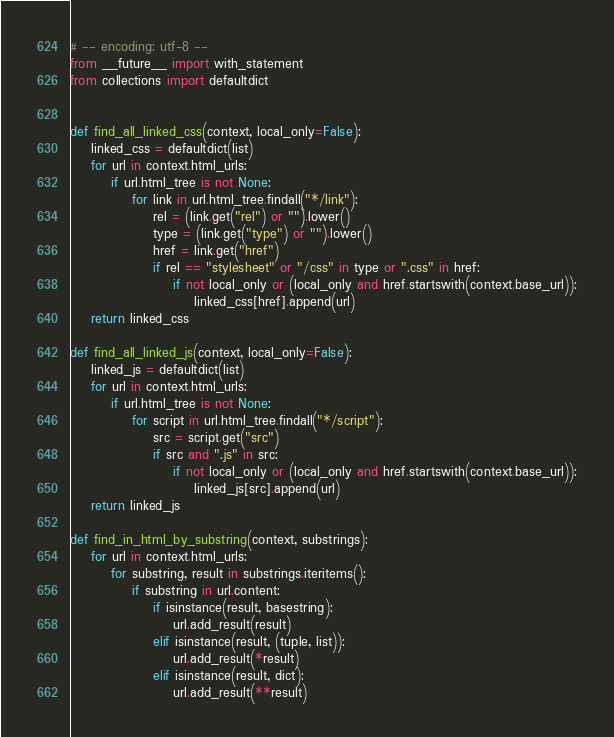Convert code to text. <code><loc_0><loc_0><loc_500><loc_500><_Python_># -- encoding: utf-8 --
from __future__ import with_statement
from collections import defaultdict


def find_all_linked_css(context, local_only=False):
	linked_css = defaultdict(list)
	for url in context.html_urls:
		if url.html_tree is not None:
			for link in url.html_tree.findall("*/link"):
				rel = (link.get("rel") or "").lower()
				type = (link.get("type") or "").lower()
				href = link.get("href")
				if rel == "stylesheet" or "/css" in type or ".css" in href:
					if not local_only or (local_only and href.startswith(context.base_url)):
						linked_css[href].append(url)
	return linked_css

def find_all_linked_js(context, local_only=False):
	linked_js = defaultdict(list)
	for url in context.html_urls:
		if url.html_tree is not None:
			for script in url.html_tree.findall("*/script"):
				src = script.get("src")
				if src and ".js" in src:
					if not local_only or (local_only and href.startswith(context.base_url)):
						linked_js[src].append(url)
	return linked_js

def find_in_html_by_substring(context, substrings):
	for url in context.html_urls:
		for substring, result in substrings.iteritems():
			if substring in url.content:
				if isinstance(result, basestring):
					url.add_result(result)
				elif isinstance(result, (tuple, list)):
					url.add_result(*result)
				elif isinstance(result, dict):
					url.add_result(**result)
</code> 